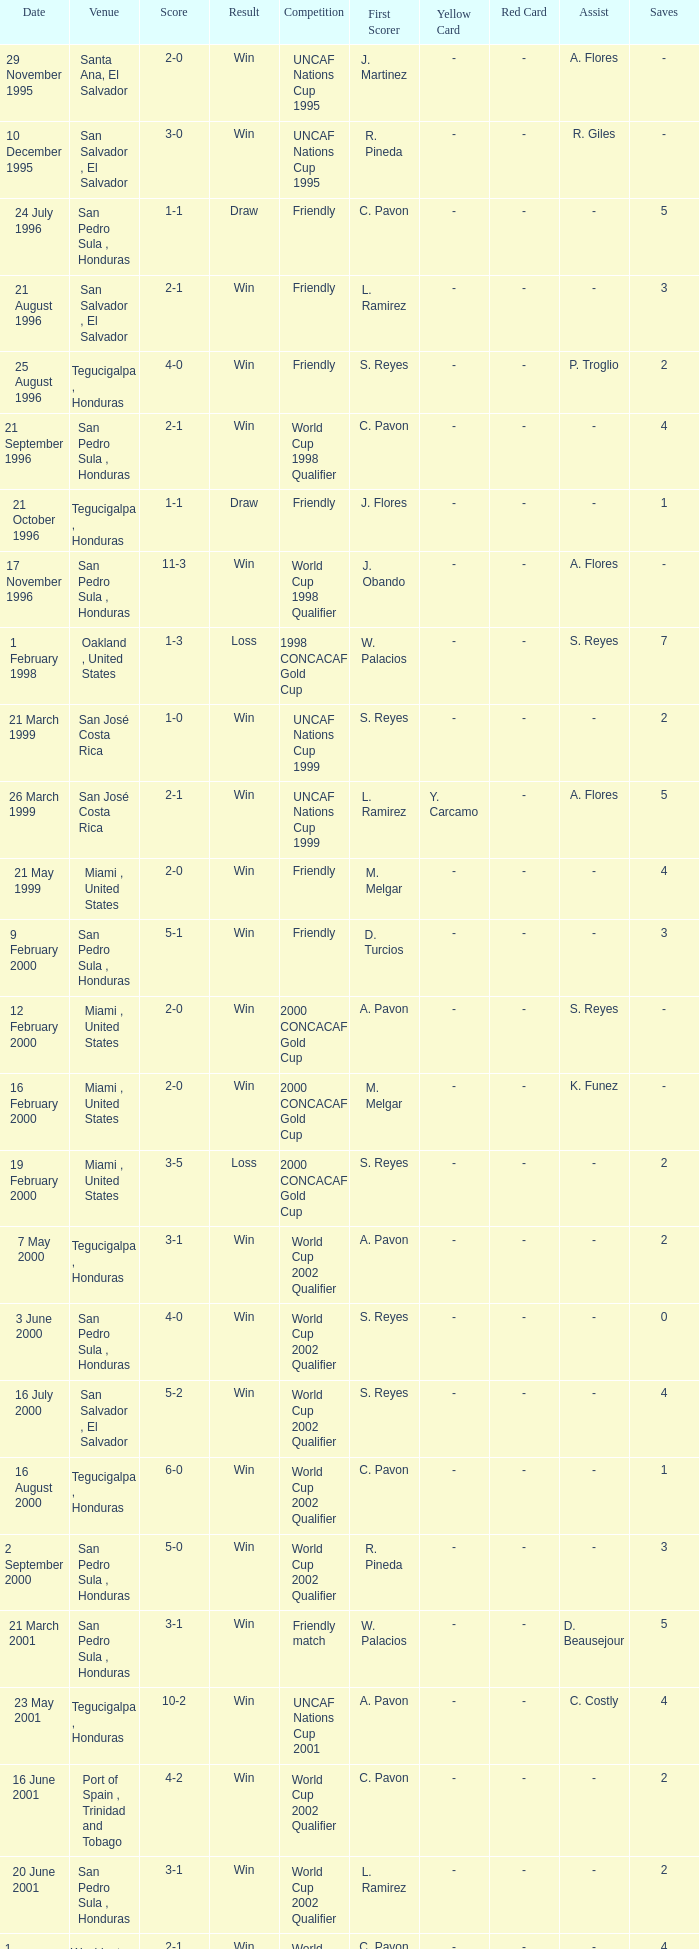Name the date of the uncaf nations cup 2009 26 January 2009. 